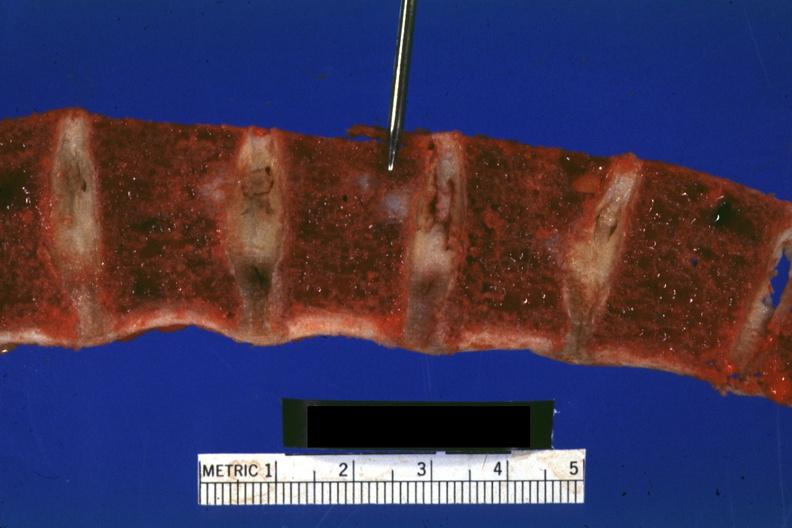what does this image show?
Answer the question using a single word or phrase. Vertebral bodies with typical gelatinous-hemorrhagic lesions 